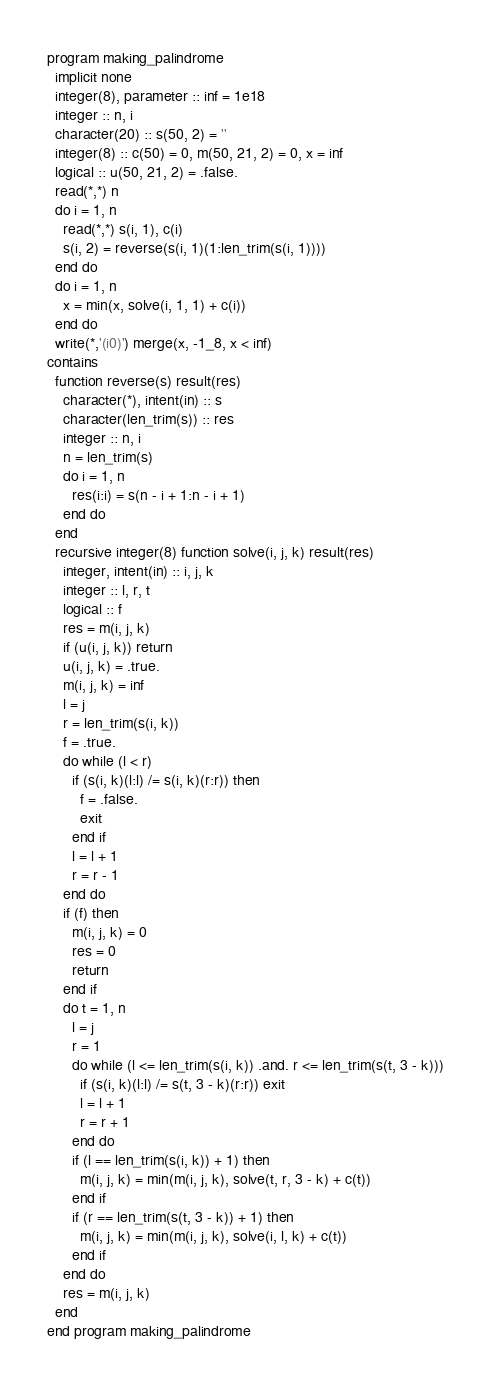<code> <loc_0><loc_0><loc_500><loc_500><_FORTRAN_>program making_palindrome
  implicit none
  integer(8), parameter :: inf = 1e18
  integer :: n, i
  character(20) :: s(50, 2) = ''
  integer(8) :: c(50) = 0, m(50, 21, 2) = 0, x = inf
  logical :: u(50, 21, 2) = .false.
  read(*,*) n
  do i = 1, n
    read(*,*) s(i, 1), c(i)
    s(i, 2) = reverse(s(i, 1)(1:len_trim(s(i, 1))))
  end do
  do i = 1, n
    x = min(x, solve(i, 1, 1) + c(i))
  end do
  write(*,'(i0)') merge(x, -1_8, x < inf)
contains
  function reverse(s) result(res)
    character(*), intent(in) :: s
    character(len_trim(s)) :: res
    integer :: n, i
    n = len_trim(s)
    do i = 1, n
      res(i:i) = s(n - i + 1:n - i + 1)
    end do
  end
  recursive integer(8) function solve(i, j, k) result(res)
    integer, intent(in) :: i, j, k
    integer :: l, r, t
    logical :: f
    res = m(i, j, k)
    if (u(i, j, k)) return
    u(i, j, k) = .true.
    m(i, j, k) = inf
    l = j
    r = len_trim(s(i, k))
    f = .true.
    do while (l < r)
      if (s(i, k)(l:l) /= s(i, k)(r:r)) then
        f = .false.
        exit
      end if
      l = l + 1
      r = r - 1
    end do
    if (f) then
      m(i, j, k) = 0
      res = 0
      return
    end if
    do t = 1, n
      l = j
      r = 1
      do while (l <= len_trim(s(i, k)) .and. r <= len_trim(s(t, 3 - k)))
        if (s(i, k)(l:l) /= s(t, 3 - k)(r:r)) exit
        l = l + 1
        r = r + 1
      end do
      if (l == len_trim(s(i, k)) + 1) then
        m(i, j, k) = min(m(i, j, k), solve(t, r, 3 - k) + c(t))
      end if
      if (r == len_trim(s(t, 3 - k)) + 1) then
        m(i, j, k) = min(m(i, j, k), solve(i, l, k) + c(t))
      end if
    end do
    res = m(i, j, k)
  end
end program making_palindrome</code> 